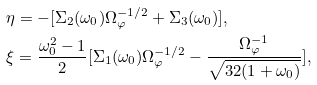Convert formula to latex. <formula><loc_0><loc_0><loc_500><loc_500>& \eta = - [ \Sigma _ { 2 } ( \omega _ { 0 } ) \Omega _ { \varphi } ^ { - 1 / 2 } + \Sigma _ { 3 } ( \omega _ { 0 } ) ] , \\ & \xi = \frac { \omega _ { 0 } ^ { 2 } - 1 } { 2 } [ \Sigma _ { 1 } ( \omega _ { 0 } ) \Omega _ { \varphi } ^ { - 1 / 2 } - \frac { \Omega _ { \varphi } ^ { - 1 } } { \sqrt { 3 2 ( 1 + \omega _ { 0 } ) } } ] ,</formula> 